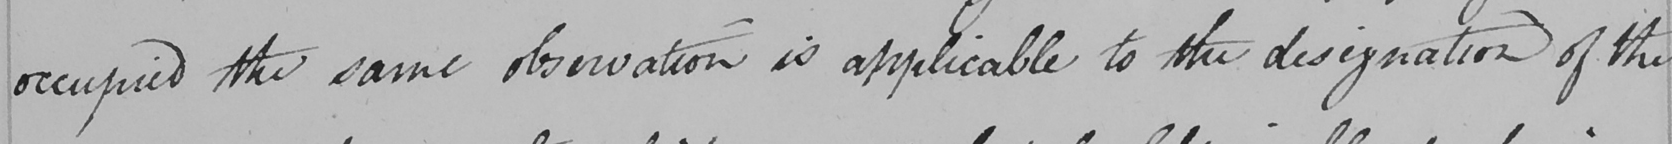Can you read and transcribe this handwriting? occupied the same observation is applicable to the designation of the 